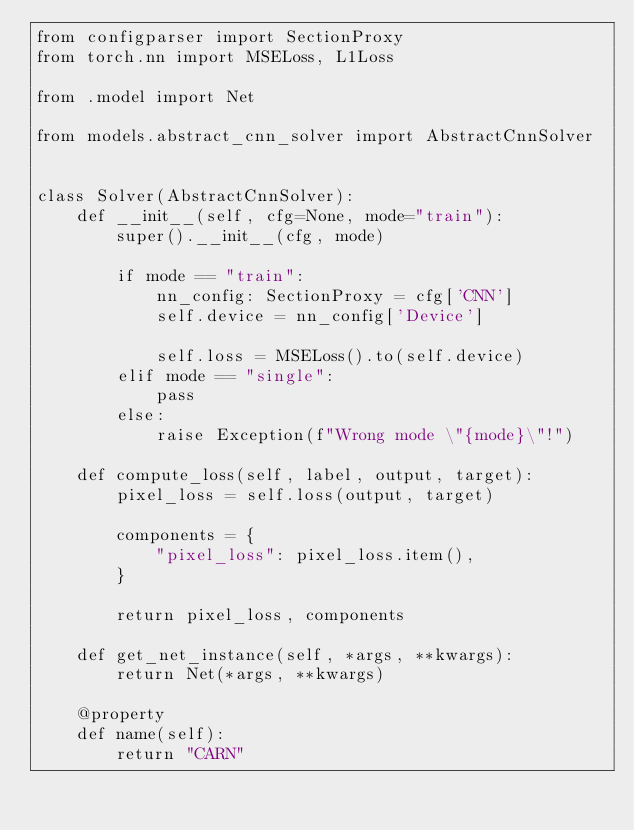<code> <loc_0><loc_0><loc_500><loc_500><_Python_>from configparser import SectionProxy
from torch.nn import MSELoss, L1Loss

from .model import Net

from models.abstract_cnn_solver import AbstractCnnSolver


class Solver(AbstractCnnSolver):
    def __init__(self, cfg=None, mode="train"):
        super().__init__(cfg, mode)

        if mode == "train":
            nn_config: SectionProxy = cfg['CNN']
            self.device = nn_config['Device']

            self.loss = MSELoss().to(self.device)
        elif mode == "single":
            pass
        else:
            raise Exception(f"Wrong mode \"{mode}\"!")

    def compute_loss(self, label, output, target):
        pixel_loss = self.loss(output, target)

        components = {
            "pixel_loss": pixel_loss.item(),
        }

        return pixel_loss, components

    def get_net_instance(self, *args, **kwargs):
        return Net(*args, **kwargs)

    @property
    def name(self):
        return "CARN"
</code> 